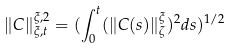<formula> <loc_0><loc_0><loc_500><loc_500>\| C \| _ { \xi , t } ^ { \xi , 2 } = ( \int _ { 0 } ^ { t } ( \| C ( s ) \| _ { \zeta } ^ { \xi } ) ^ { 2 } d s ) ^ { 1 / 2 }</formula> 